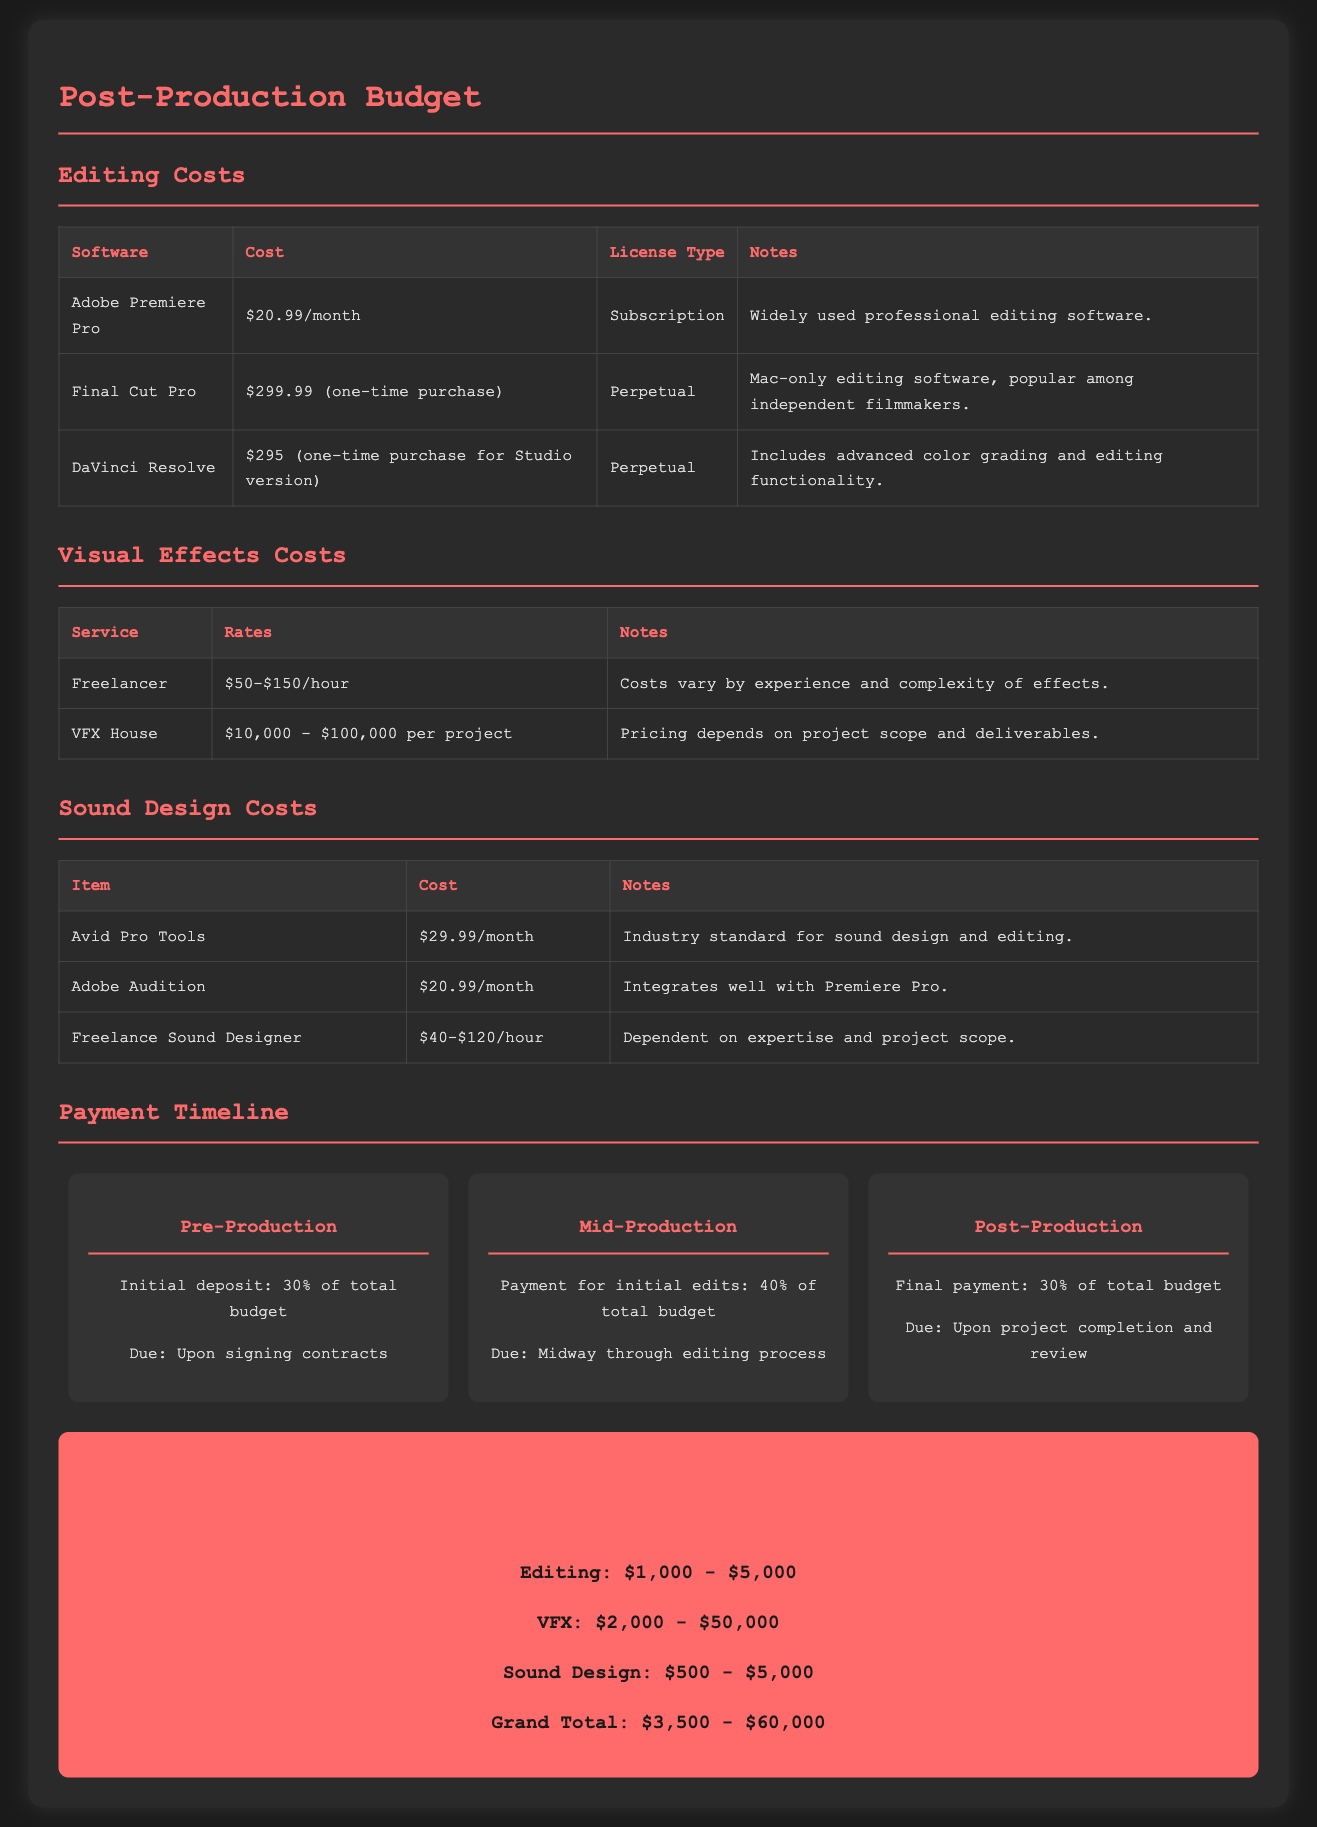What is the cost of Adobe Premiere Pro? The cost of Adobe Premiere Pro is listed in the editing costs section of the document.
Answer: $20.99/month What is the maximum estimated cost for VFX services? The maximum estimated cost for VFX is found in the visual effects costs section.
Answer: $100,000 What is the initial deposit percentage due at pre-production? The initial deposit percentage is specified in the payment timeline section.
Answer: 30% What is the total estimated budget for sound design? The total estimated budget for sound design is calculated from the sound design costs section.
Answer: $500 - $5,000 How much does a freelance sound designer charge per hour? The hourly charge for a freelance sound designer is provided in the sound design costs section.
Answer: $40-$120/hour What software requires a one-time purchase for editing? The software that requires a one-time purchase is listed in the editing costs section.
Answer: Final Cut Pro What is the payment due at mid-production? The payment due at mid-production is specified in the payment timeline section.
Answer: 40% of total budget What is included in the Adobe Audition costs? Adobe Audition costs detail is provided in the sound design costs section of the document.
Answer: $20.99/month 